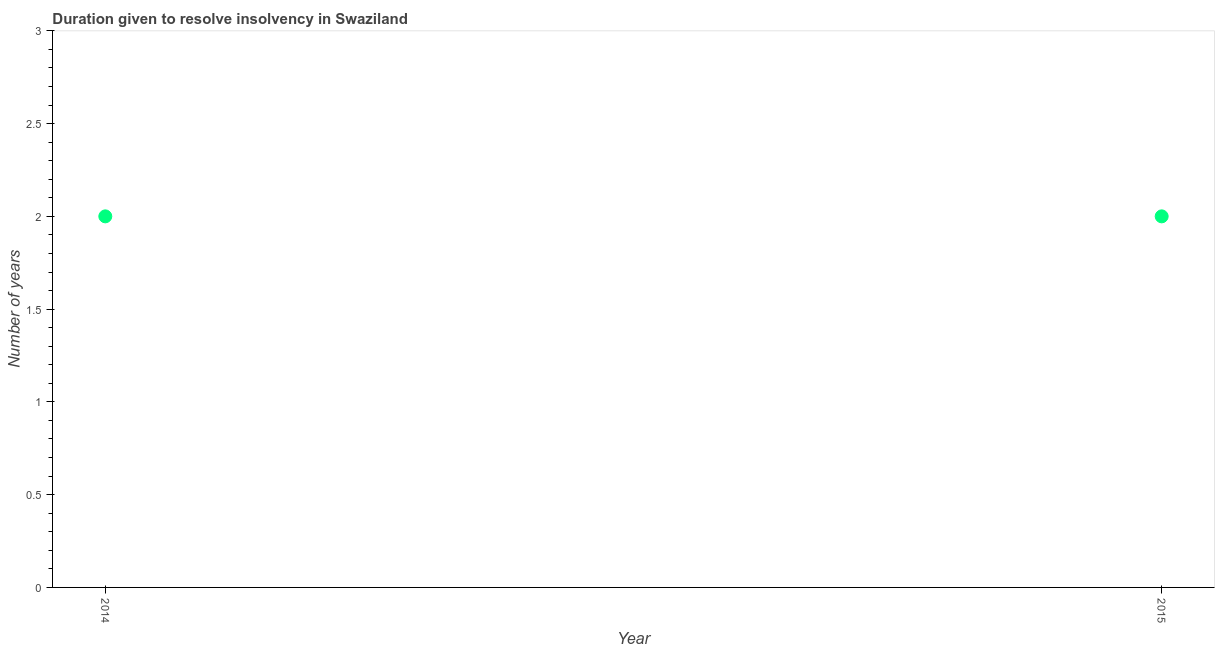What is the number of years to resolve insolvency in 2014?
Keep it short and to the point. 2. Across all years, what is the maximum number of years to resolve insolvency?
Ensure brevity in your answer.  2. Across all years, what is the minimum number of years to resolve insolvency?
Provide a succinct answer. 2. In which year was the number of years to resolve insolvency minimum?
Ensure brevity in your answer.  2014. What is the sum of the number of years to resolve insolvency?
Offer a terse response. 4. What is the ratio of the number of years to resolve insolvency in 2014 to that in 2015?
Offer a terse response. 1. How many dotlines are there?
Provide a succinct answer. 1. What is the difference between two consecutive major ticks on the Y-axis?
Provide a short and direct response. 0.5. Are the values on the major ticks of Y-axis written in scientific E-notation?
Offer a terse response. No. Does the graph contain grids?
Your answer should be compact. No. What is the title of the graph?
Offer a very short reply. Duration given to resolve insolvency in Swaziland. What is the label or title of the Y-axis?
Offer a terse response. Number of years. What is the difference between the Number of years in 2014 and 2015?
Provide a succinct answer. 0. 